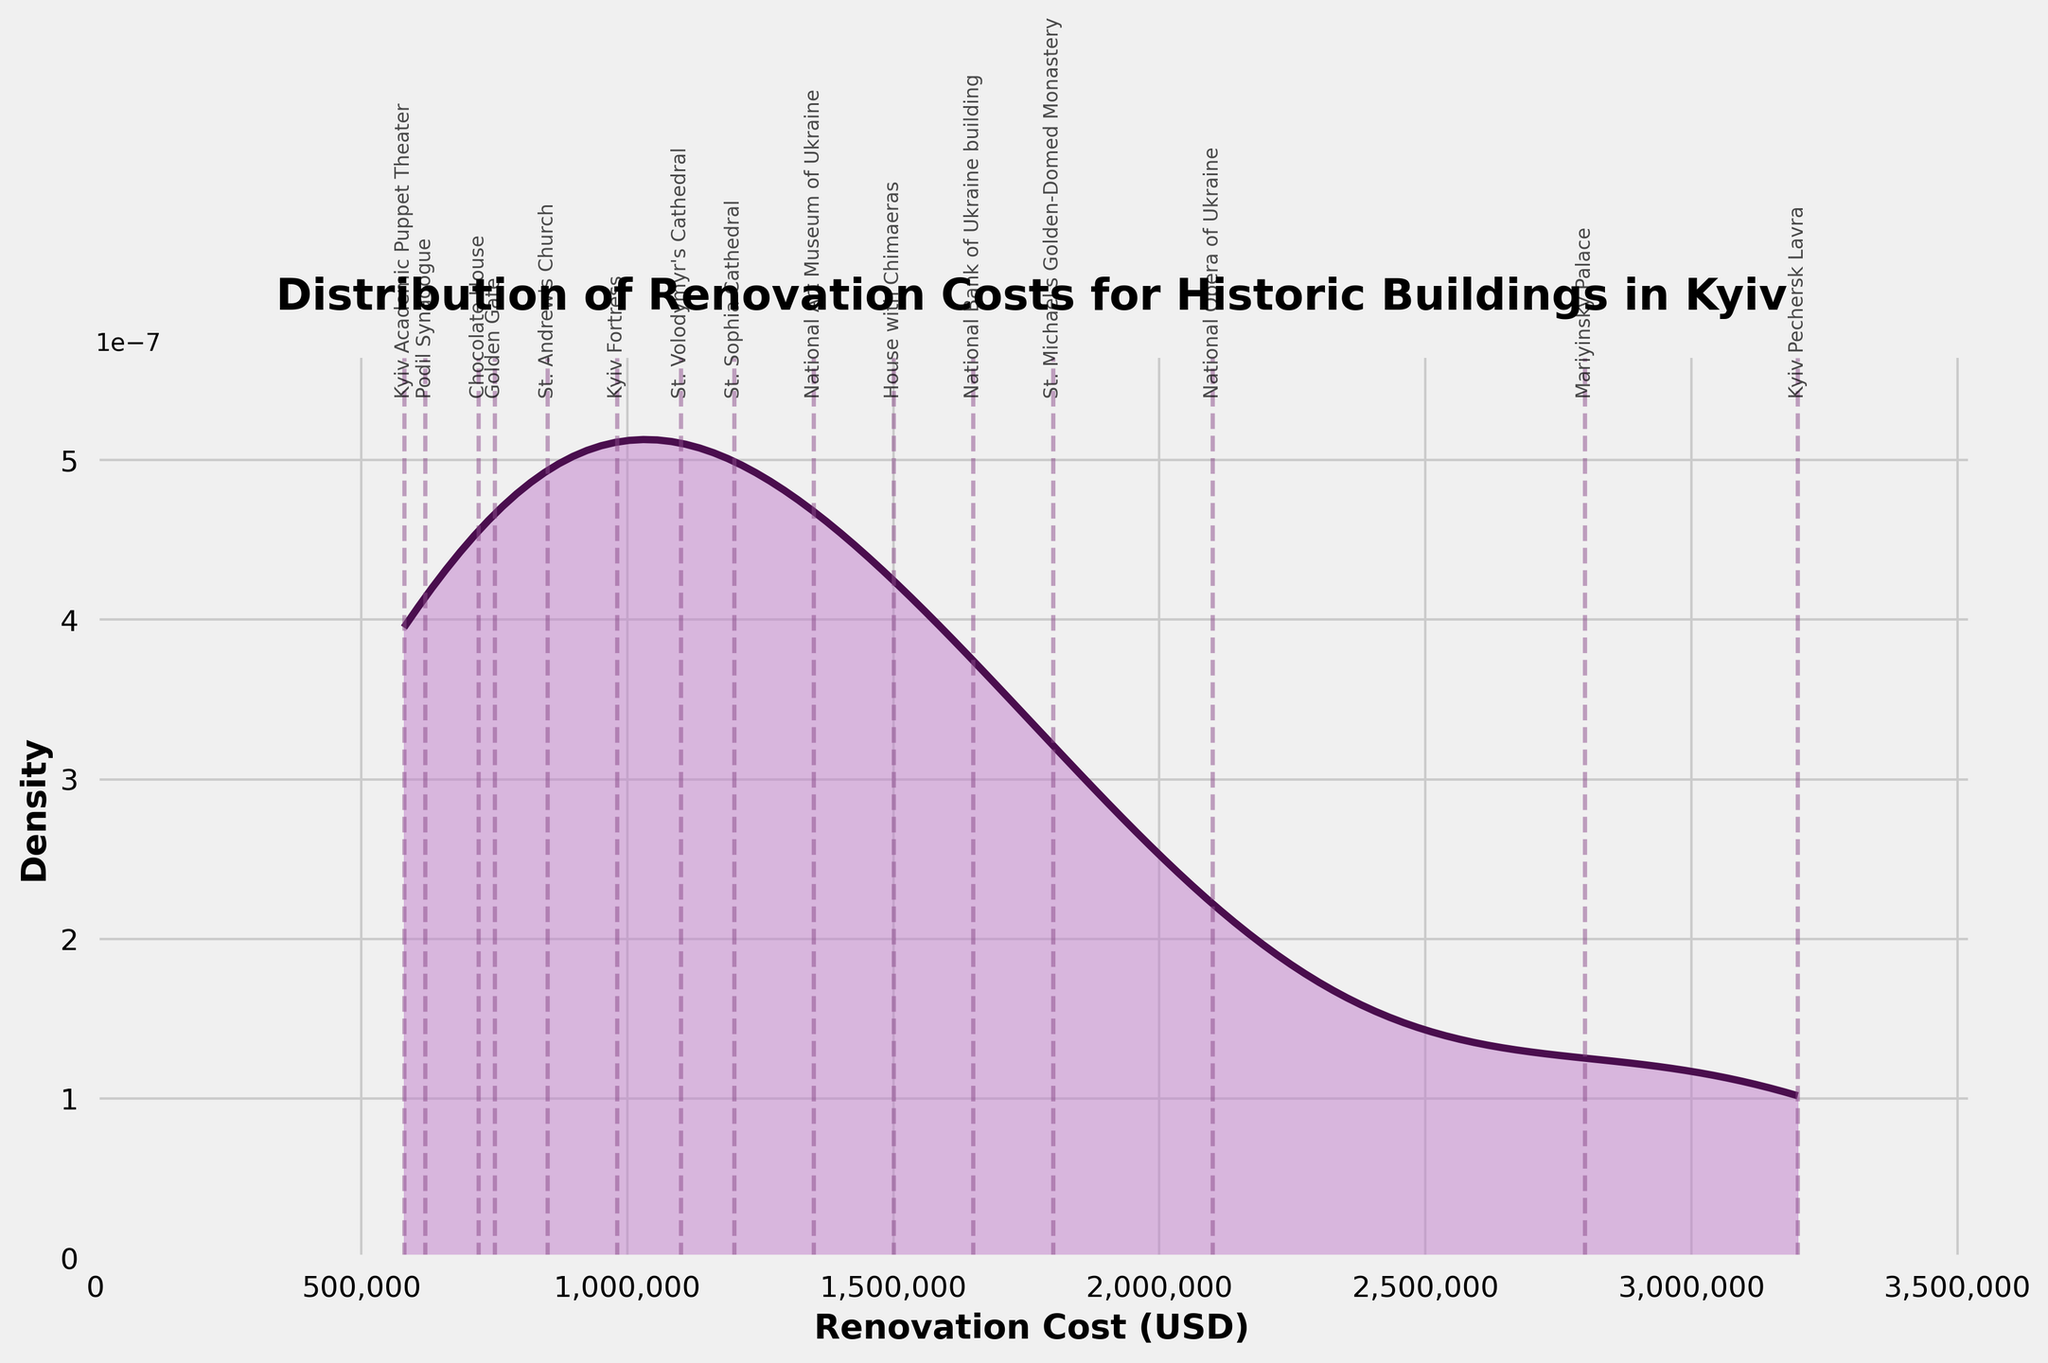What is the peak density value on the plot? The peak density value can be identified by looking at the highest point on the density curve. The y-axis shows the density values.
Answer: At the maximum point on the density curve Which building has the highest renovation cost? The building with the highest renovation cost can be identified by looking for the furthest right vertical line on the x-axis, where the building names are labeled.
Answer: Kyiv Pechersk Lavra What is the range of renovation costs displayed? The range of renovation costs can be found by identifying the minimum and maximum values on the x-axis. The axis labels and the spread of the vertical lines will show this range.
Answer: $580,000 to $3,200,000 How many buildings have renovation costs over 1 million dollars? Buildings with renovation costs over 1 million dollars can be identified by observing the labeled vertical lines on the right side of the 1 million mark on the x-axis.
Answer: 9 Which building has the lowest renovation cost? The building with the lowest renovation cost can be identified by looking for the furthest left vertical line on the x-axis where the building names are labeled.
Answer: Kyiv Academic Puppet Theater What is the spread of the majority of the renovation costs? The spread of the majority of costs can be approximated by looking at the bulk of the density curve's area between significant peaks and dips.
Answer: Between $720,000 and $2,100,000 What is the approximate density value for the National Opera of Ukraine? Identify the vertical line corresponding to the National Opera of Ukraine and trace horizontally to the density curve to read the approximate value from the y-axis.
Answer: Near the y-axis value at 2.1 million Which buildings have renovation costs closest to the average renovation cost? Calculate the average of the renovation costs and then identify the buildings whose vertical lines are closest to this average on the x-axis.
Answer: (Average) Approximately $1,479,333.33; Closest buildings: St. Andrew's Church and House with Chimaeras What is the distance between the renovation costs of Mariyinsky Palace and House with Chimaeras? Find the vertical lines for both Mariyinsky Palace and House with Chimaeras and calculate the difference between these x-axis values.
Answer: $2,800,000 - $1,500,000 = $1,300,000 What's the average renovation cost for these buildings? Sum up all the renovation costs and divide by the number of buildings: (1200000 + 850000 + 1500000 + 2800000 + 2100000 + 750000 + 1800000 + 980000 + 620000 + 1350000 + 3200000 + 1100000 + 580000 + 720000 + 1650000) / 15.
Answer: $1,479,333.33 